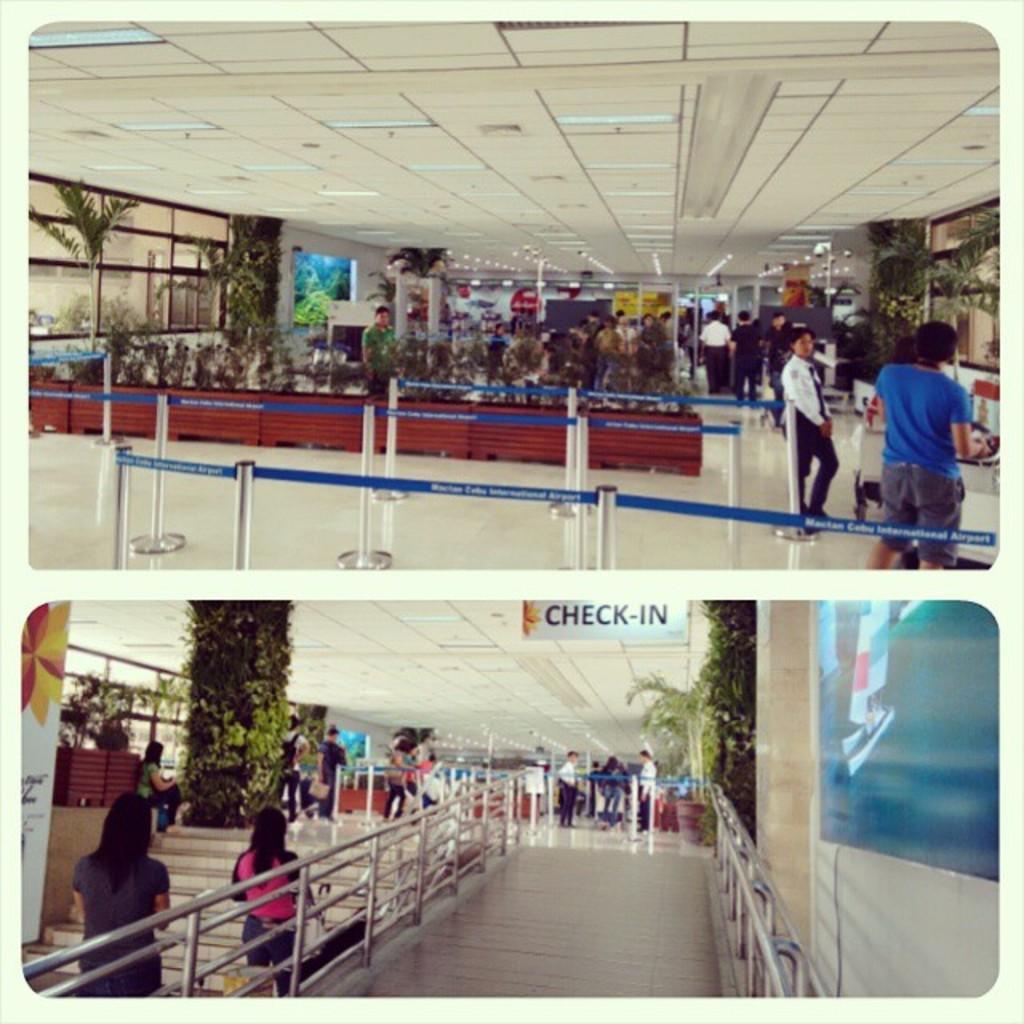Please provide a concise description of this image. In the foreground of this collage image, we can see trees, safety poles, railing, ceiling, few boards, screens, people walking and standing, stairs and the floor. 